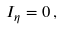Convert formula to latex. <formula><loc_0><loc_0><loc_500><loc_500>I _ { \eta } = 0 \, ,</formula> 